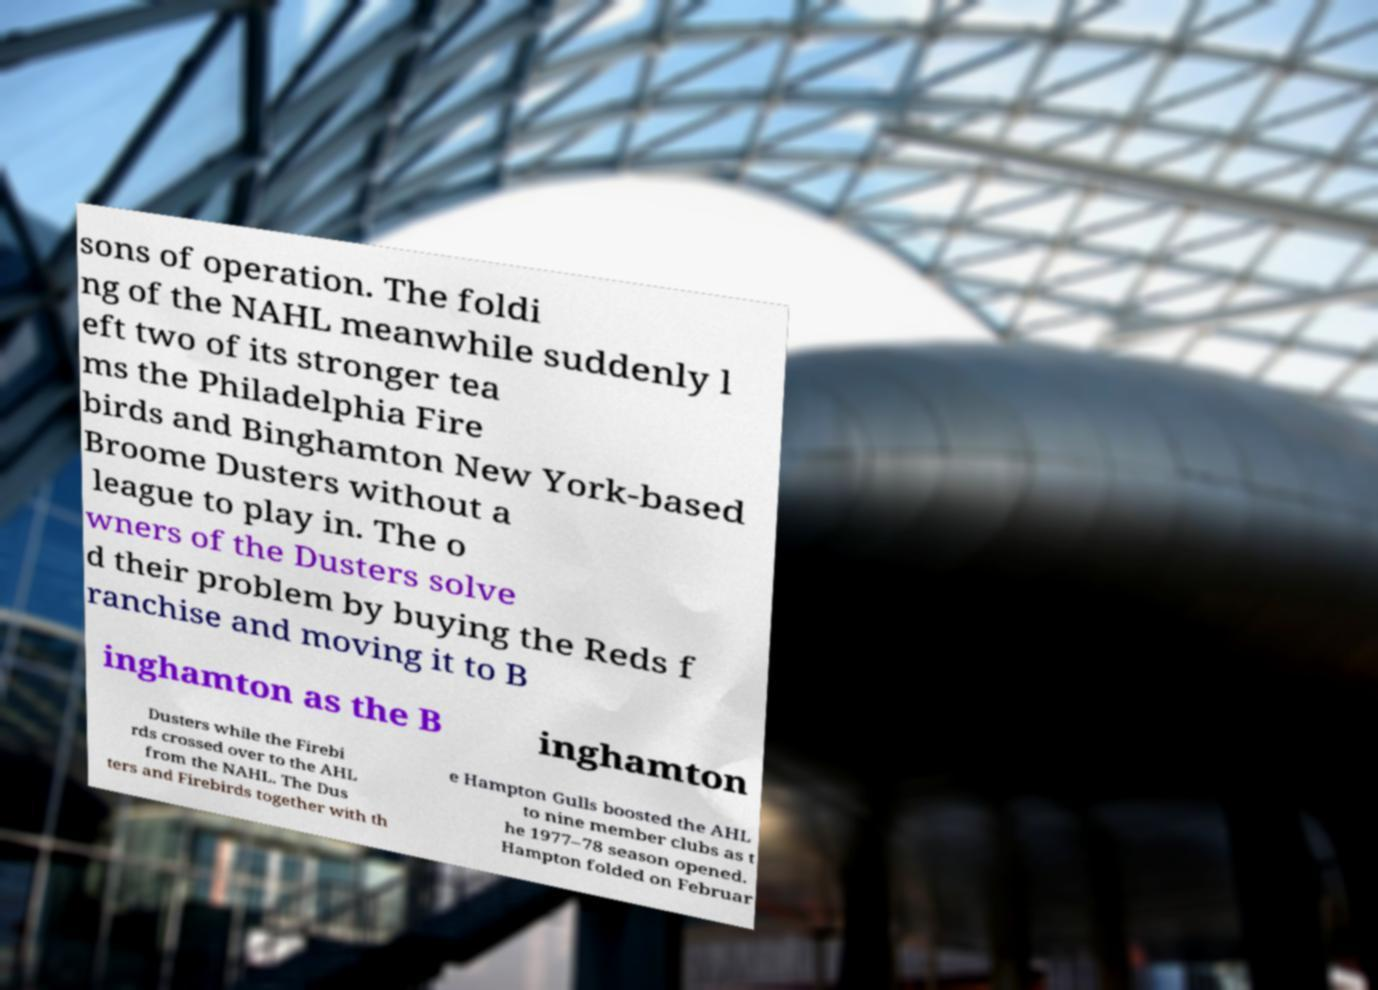Could you assist in decoding the text presented in this image and type it out clearly? sons of operation. The foldi ng of the NAHL meanwhile suddenly l eft two of its stronger tea ms the Philadelphia Fire birds and Binghamton New York-based Broome Dusters without a league to play in. The o wners of the Dusters solve d their problem by buying the Reds f ranchise and moving it to B inghamton as the B inghamton Dusters while the Firebi rds crossed over to the AHL from the NAHL. The Dus ters and Firebirds together with th e Hampton Gulls boosted the AHL to nine member clubs as t he 1977–78 season opened. Hampton folded on Februar 